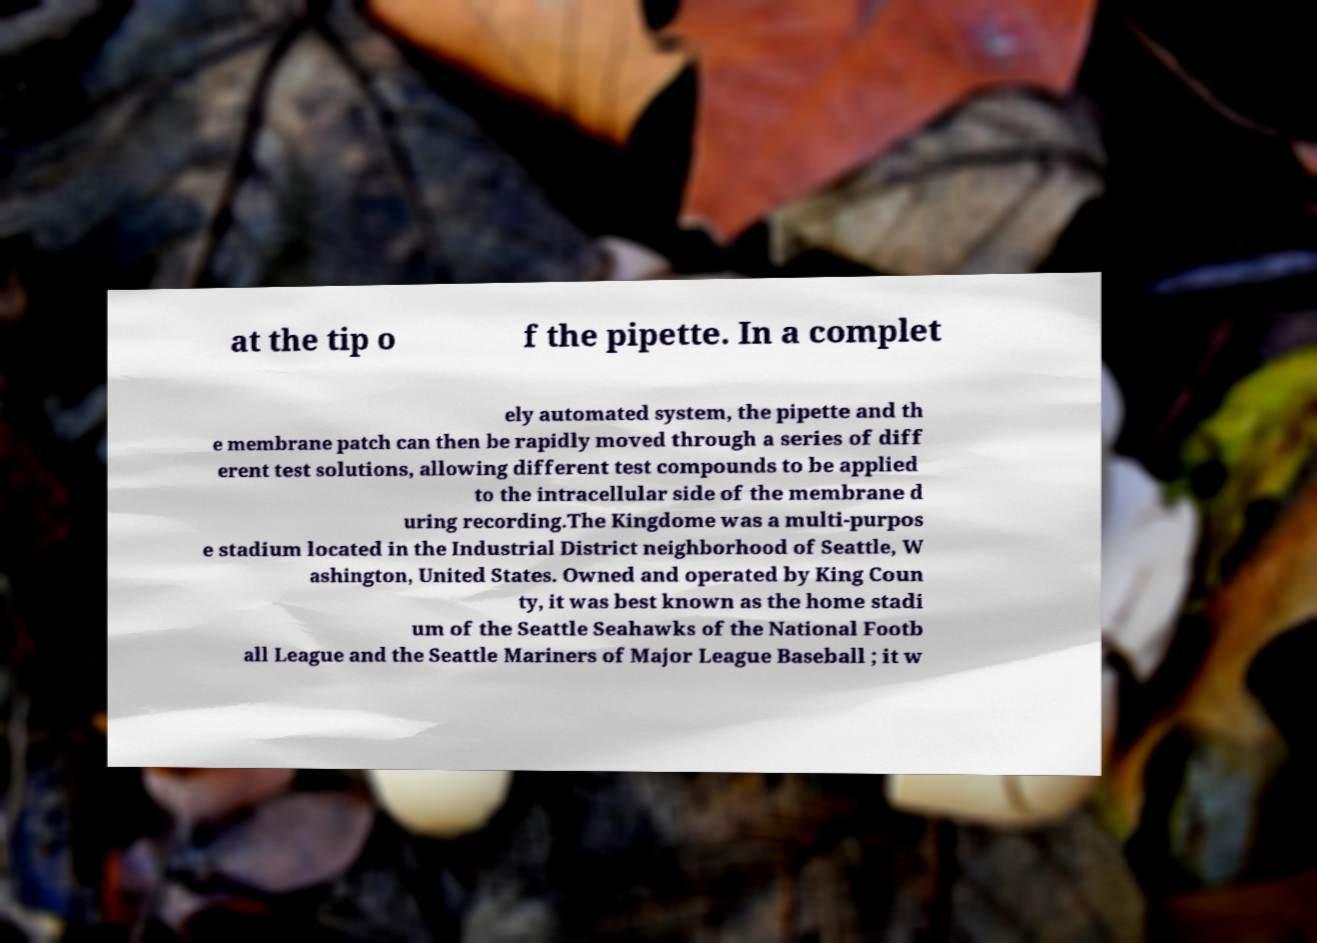Could you extract and type out the text from this image? at the tip o f the pipette. In a complet ely automated system, the pipette and th e membrane patch can then be rapidly moved through a series of diff erent test solutions, allowing different test compounds to be applied to the intracellular side of the membrane d uring recording.The Kingdome was a multi-purpos e stadium located in the Industrial District neighborhood of Seattle, W ashington, United States. Owned and operated by King Coun ty, it was best known as the home stadi um of the Seattle Seahawks of the National Footb all League and the Seattle Mariners of Major League Baseball ; it w 